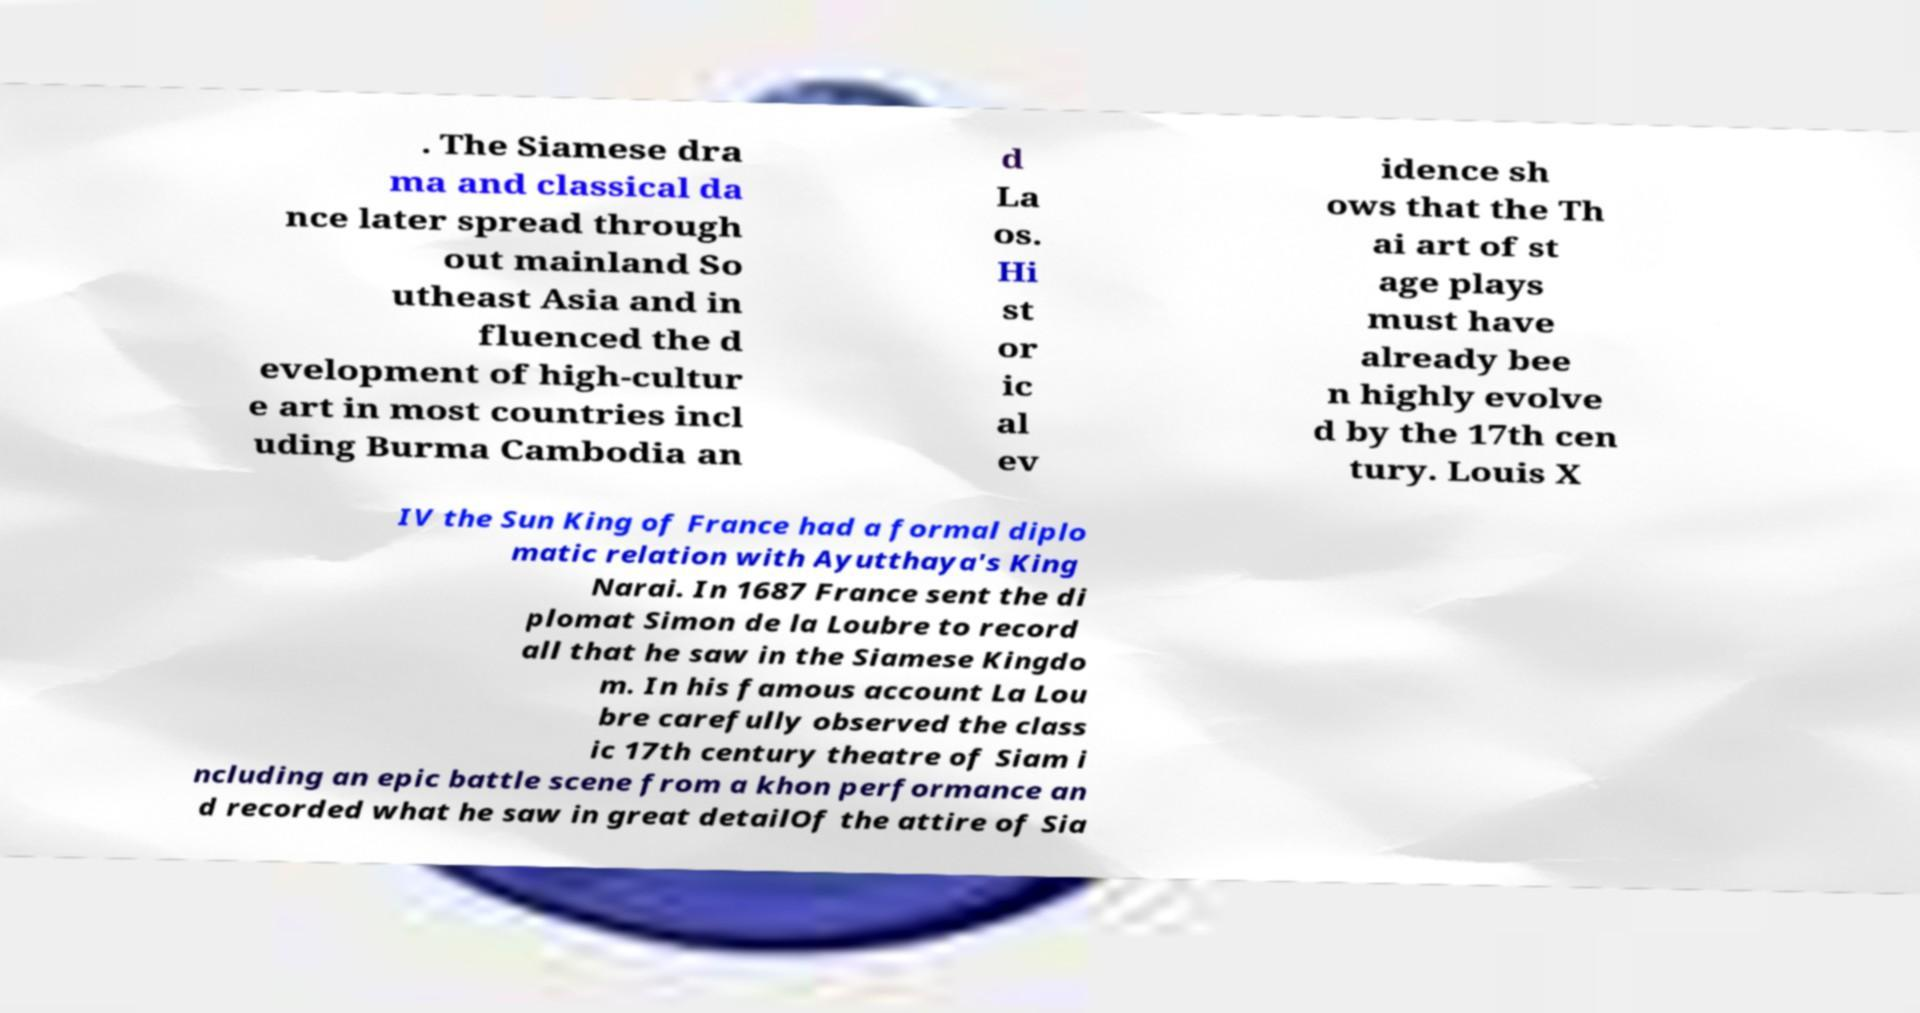Could you extract and type out the text from this image? . The Siamese dra ma and classical da nce later spread through out mainland So utheast Asia and in fluenced the d evelopment of high-cultur e art in most countries incl uding Burma Cambodia an d La os. Hi st or ic al ev idence sh ows that the Th ai art of st age plays must have already bee n highly evolve d by the 17th cen tury. Louis X IV the Sun King of France had a formal diplo matic relation with Ayutthaya's King Narai. In 1687 France sent the di plomat Simon de la Loubre to record all that he saw in the Siamese Kingdo m. In his famous account La Lou bre carefully observed the class ic 17th century theatre of Siam i ncluding an epic battle scene from a khon performance an d recorded what he saw in great detailOf the attire of Sia 